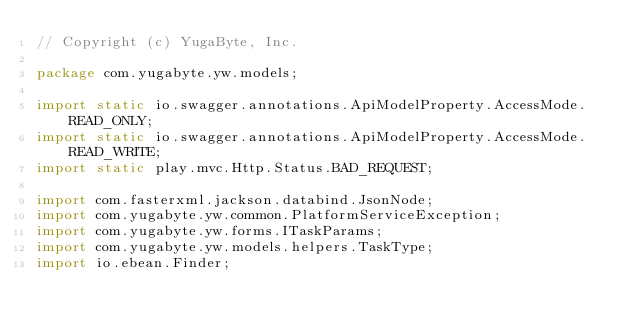<code> <loc_0><loc_0><loc_500><loc_500><_Java_>// Copyright (c) YugaByte, Inc.

package com.yugabyte.yw.models;

import static io.swagger.annotations.ApiModelProperty.AccessMode.READ_ONLY;
import static io.swagger.annotations.ApiModelProperty.AccessMode.READ_WRITE;
import static play.mvc.Http.Status.BAD_REQUEST;

import com.fasterxml.jackson.databind.JsonNode;
import com.yugabyte.yw.common.PlatformServiceException;
import com.yugabyte.yw.forms.ITaskParams;
import com.yugabyte.yw.models.helpers.TaskType;
import io.ebean.Finder;</code> 